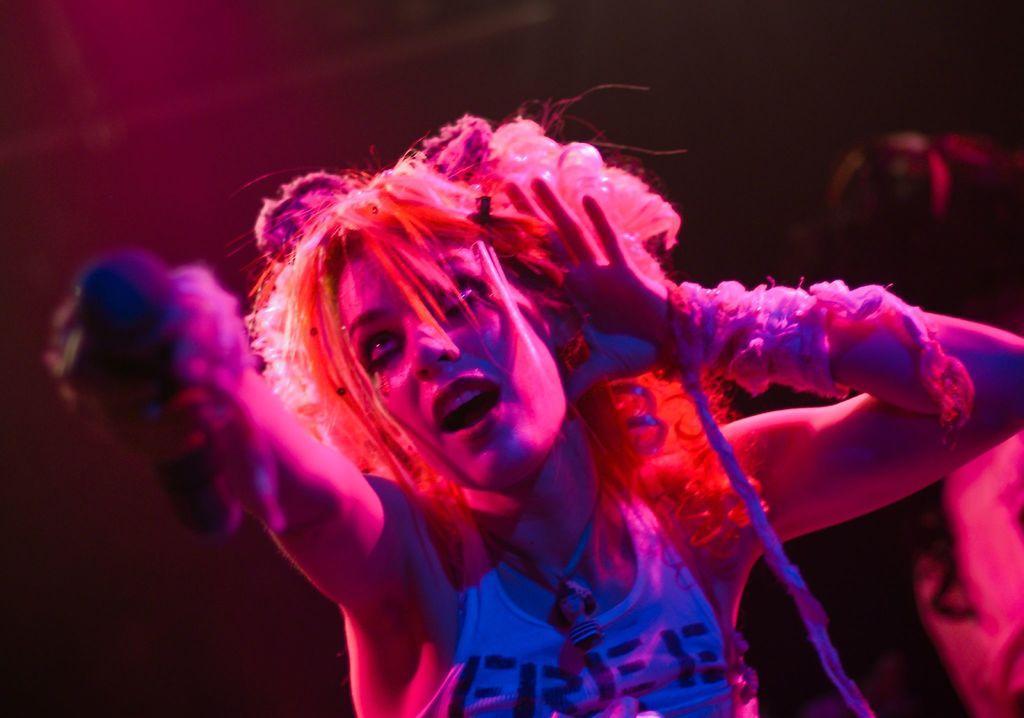Could you give a brief overview of what you see in this image? In the center of the image there is a lady holding a mic in his hand. In the background of the image there is another person. 